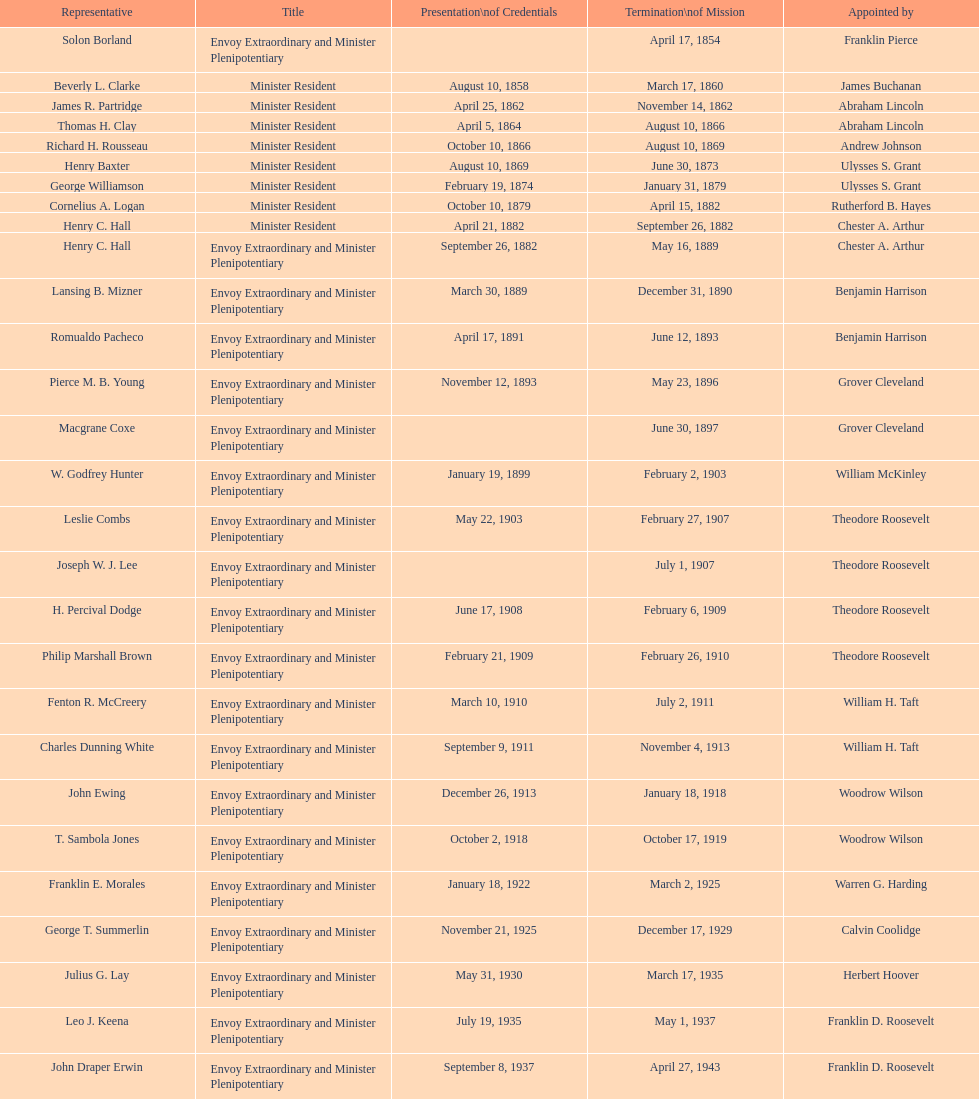Which envoy to honduras had the lengthiest tenure? Henry C. Hall. 